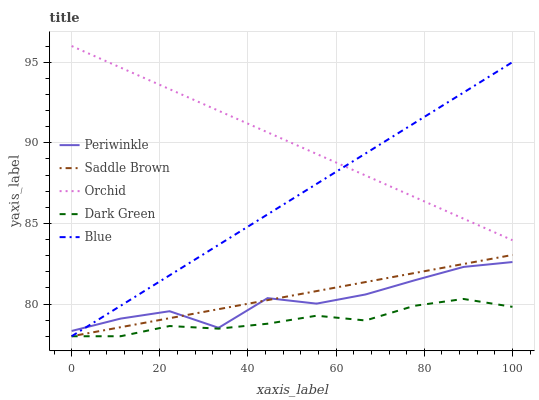Does Dark Green have the minimum area under the curve?
Answer yes or no. Yes. Does Orchid have the maximum area under the curve?
Answer yes or no. Yes. Does Periwinkle have the minimum area under the curve?
Answer yes or no. No. Does Periwinkle have the maximum area under the curve?
Answer yes or no. No. Is Blue the smoothest?
Answer yes or no. Yes. Is Periwinkle the roughest?
Answer yes or no. Yes. Is Dark Green the smoothest?
Answer yes or no. No. Is Dark Green the roughest?
Answer yes or no. No. Does Blue have the lowest value?
Answer yes or no. Yes. Does Periwinkle have the lowest value?
Answer yes or no. No. Does Orchid have the highest value?
Answer yes or no. Yes. Does Periwinkle have the highest value?
Answer yes or no. No. Is Saddle Brown less than Orchid?
Answer yes or no. Yes. Is Orchid greater than Dark Green?
Answer yes or no. Yes. Does Blue intersect Orchid?
Answer yes or no. Yes. Is Blue less than Orchid?
Answer yes or no. No. Is Blue greater than Orchid?
Answer yes or no. No. Does Saddle Brown intersect Orchid?
Answer yes or no. No. 